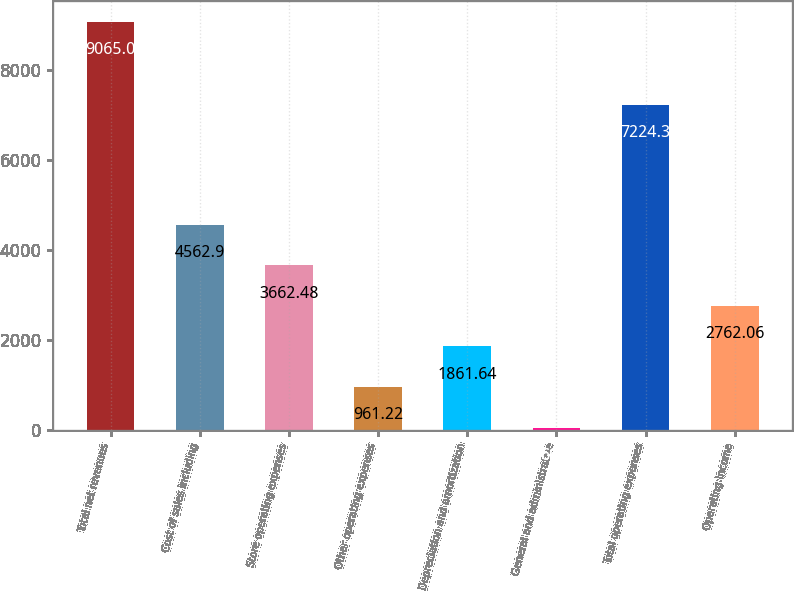Convert chart. <chart><loc_0><loc_0><loc_500><loc_500><bar_chart><fcel>Total net revenues<fcel>Cost of sales including<fcel>Store operating expenses<fcel>Other operating expenses<fcel>Depreciation and amortization<fcel>General and administrative<fcel>Total operating expenses<fcel>Operating income<nl><fcel>9065<fcel>4562.9<fcel>3662.48<fcel>961.22<fcel>1861.64<fcel>60.8<fcel>7224.3<fcel>2762.06<nl></chart> 